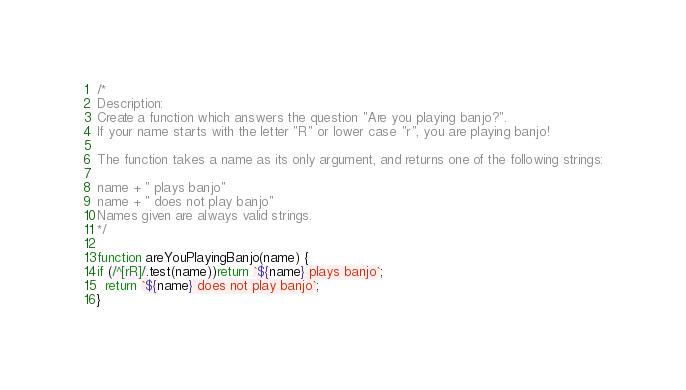<code> <loc_0><loc_0><loc_500><loc_500><_JavaScript_>/*
Description:
Create a function which answers the question "Are you playing banjo?".
If your name starts with the letter "R" or lower case "r", you are playing banjo!

The function takes a name as its only argument, and returns one of the following strings:

name + " plays banjo" 
name + " does not play banjo"
Names given are always valid strings.
*/

function areYouPlayingBanjo(name) {
if (/^[rR]/.test(name))return `${name} plays banjo`;
  return `${name} does not play banjo`;
}
</code> 